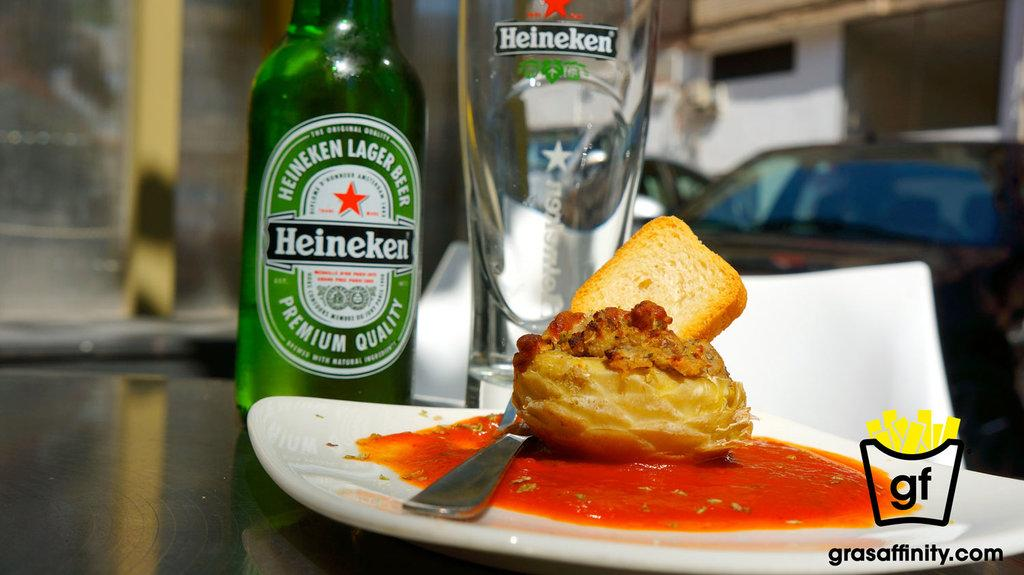What is the main subject of the image? The image highlights food. What is on the table in the image? There is a plate, a spoon, a bottle, a glass, and food on the table. Can you describe the vehicles in the distance? There are vehicles in the distance, but no specific details about them are provided. What else can be seen in the image besides the table and food? There is a building in the image. What type of authority figure can be seen in the image? There is no authority figure present in the image. Is there a parcel on the table in the image? The provided facts do not mention a parcel on the table, so it cannot be confirmed or denied. Can you see any worms in the image? There are no worms present in the image. 